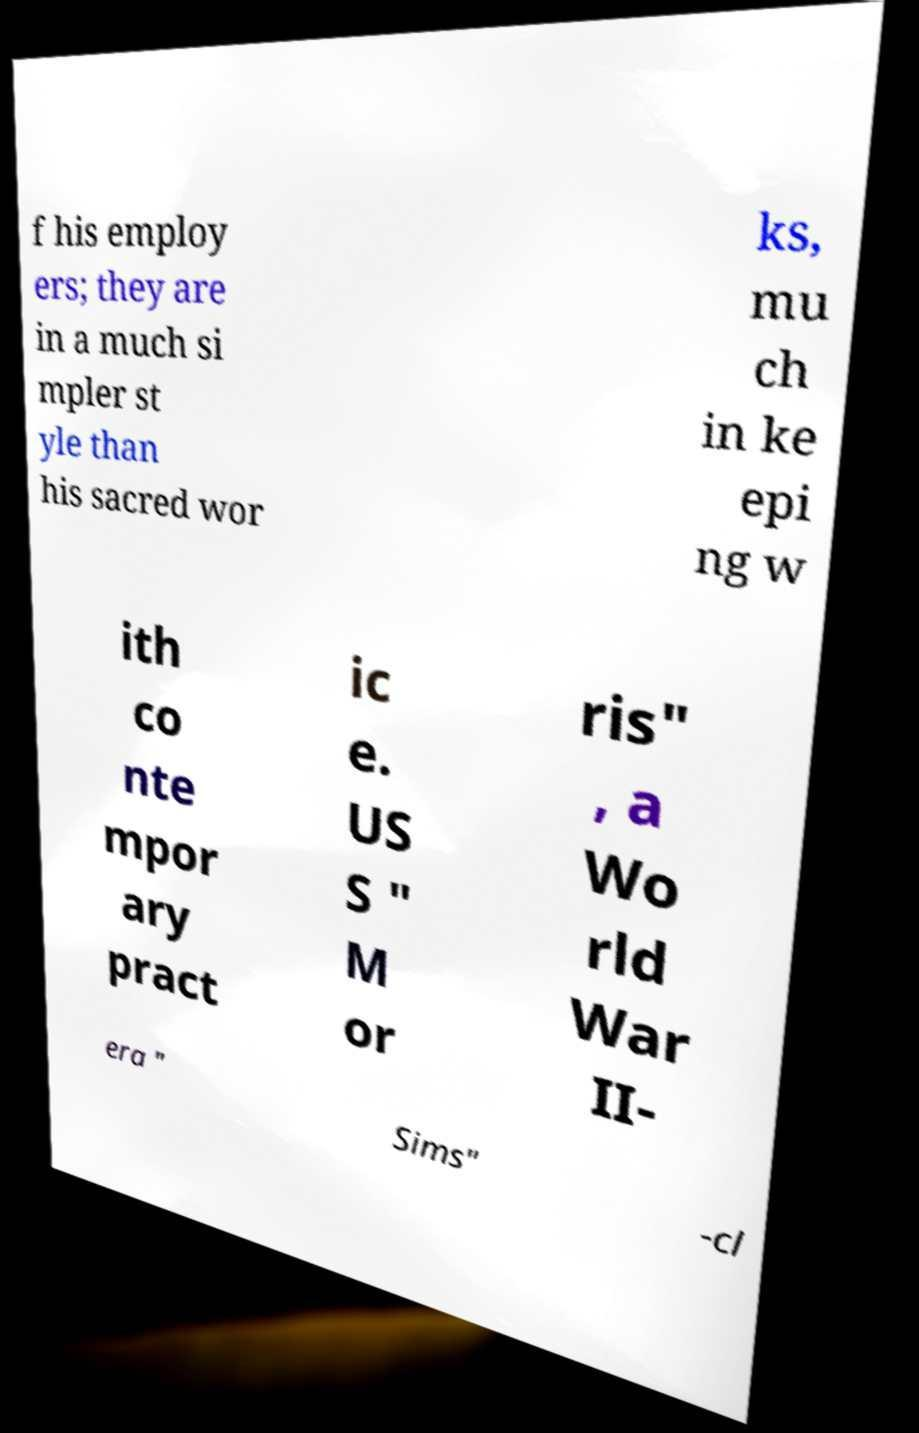What messages or text are displayed in this image? I need them in a readable, typed format. f his employ ers; they are in a much si mpler st yle than his sacred wor ks, mu ch in ke epi ng w ith co nte mpor ary pract ic e. US S " M or ris" , a Wo rld War II- era " Sims" -cl 